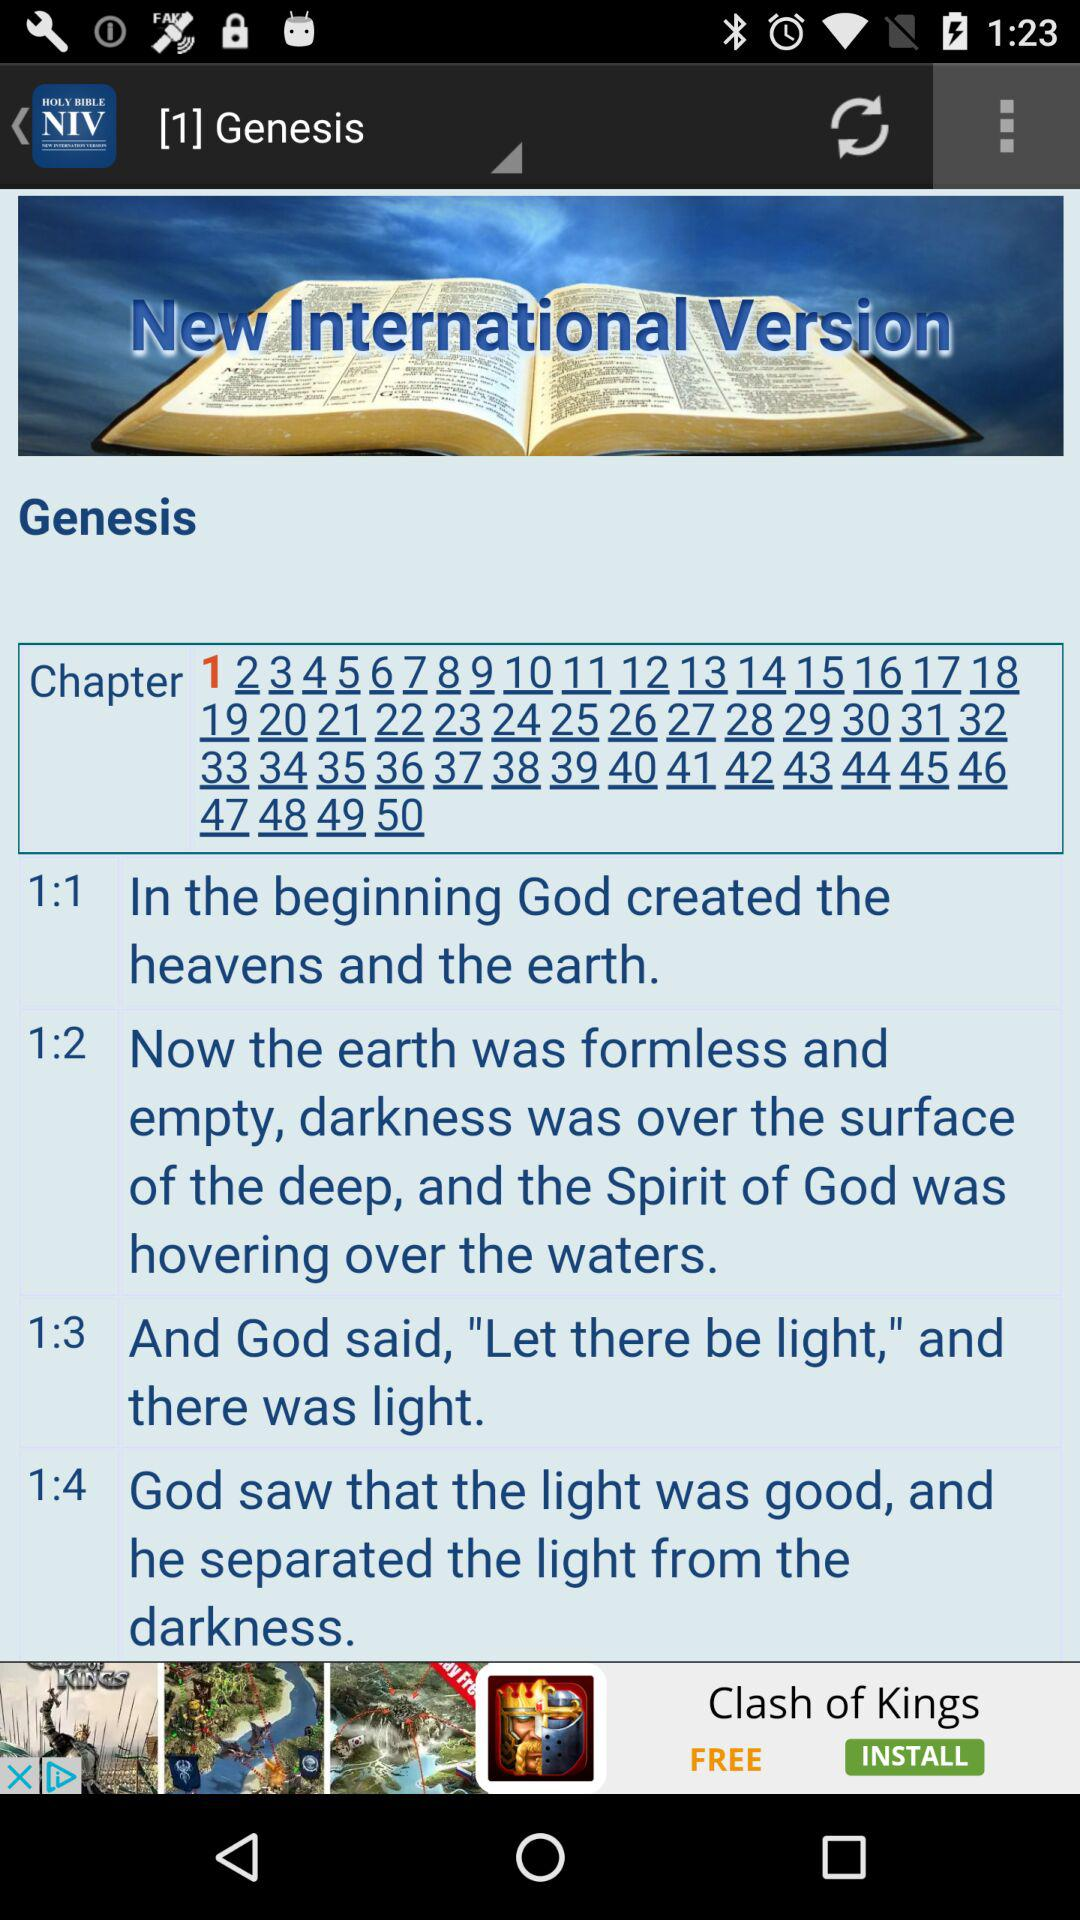How many verses are there in Genesis 1?
Answer the question using a single word or phrase. 4 